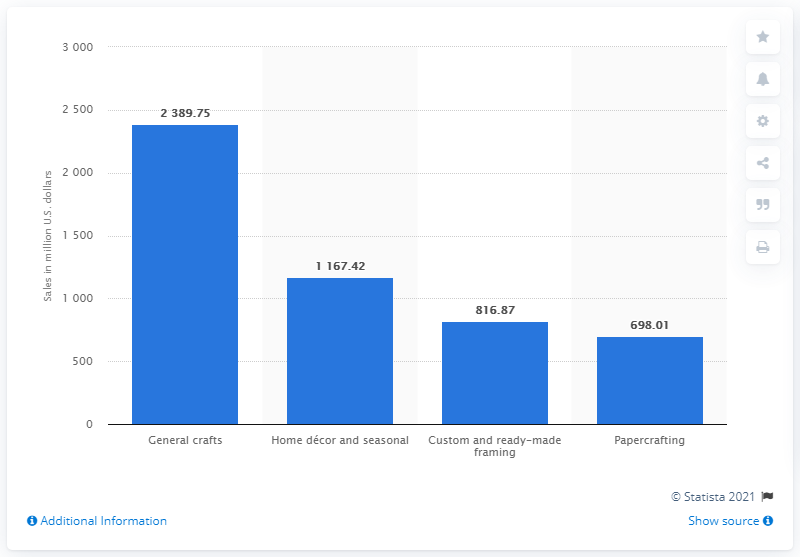Draw attention to some important aspects in this diagram. In 2019, the company's general crafts segment generated sales of 2389.75. 